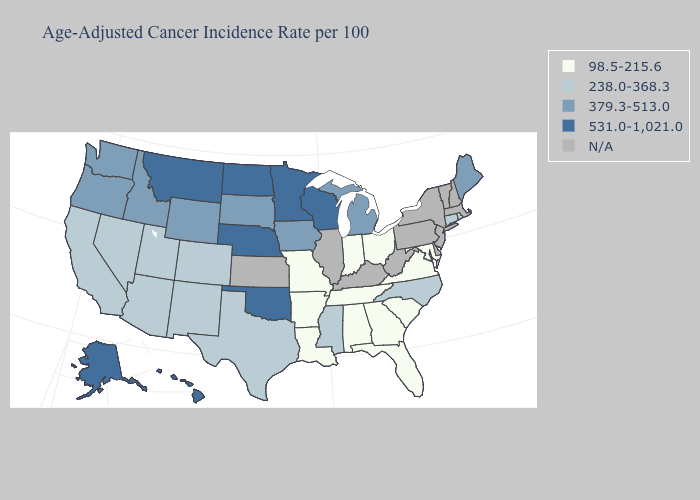Among the states that border Nebraska , which have the lowest value?
Concise answer only. Missouri. Which states have the lowest value in the USA?
Quick response, please. Alabama, Arkansas, Florida, Georgia, Indiana, Louisiana, Maryland, Missouri, Ohio, South Carolina, Tennessee, Virginia. What is the lowest value in states that border Missouri?
Write a very short answer. 98.5-215.6. What is the value of Louisiana?
Concise answer only. 98.5-215.6. What is the value of South Dakota?
Quick response, please. 379.3-513.0. Name the states that have a value in the range 379.3-513.0?
Write a very short answer. Idaho, Iowa, Maine, Michigan, Oregon, South Dakota, Washington, Wyoming. Which states hav the highest value in the Northeast?
Give a very brief answer. Maine. What is the value of Tennessee?
Keep it brief. 98.5-215.6. What is the value of Maine?
Answer briefly. 379.3-513.0. How many symbols are there in the legend?
Quick response, please. 5. What is the value of North Dakota?
Write a very short answer. 531.0-1,021.0. What is the value of Idaho?
Quick response, please. 379.3-513.0. Name the states that have a value in the range N/A?
Answer briefly. Delaware, Illinois, Kansas, Kentucky, Massachusetts, New Hampshire, New Jersey, New York, Pennsylvania, Vermont, West Virginia. 